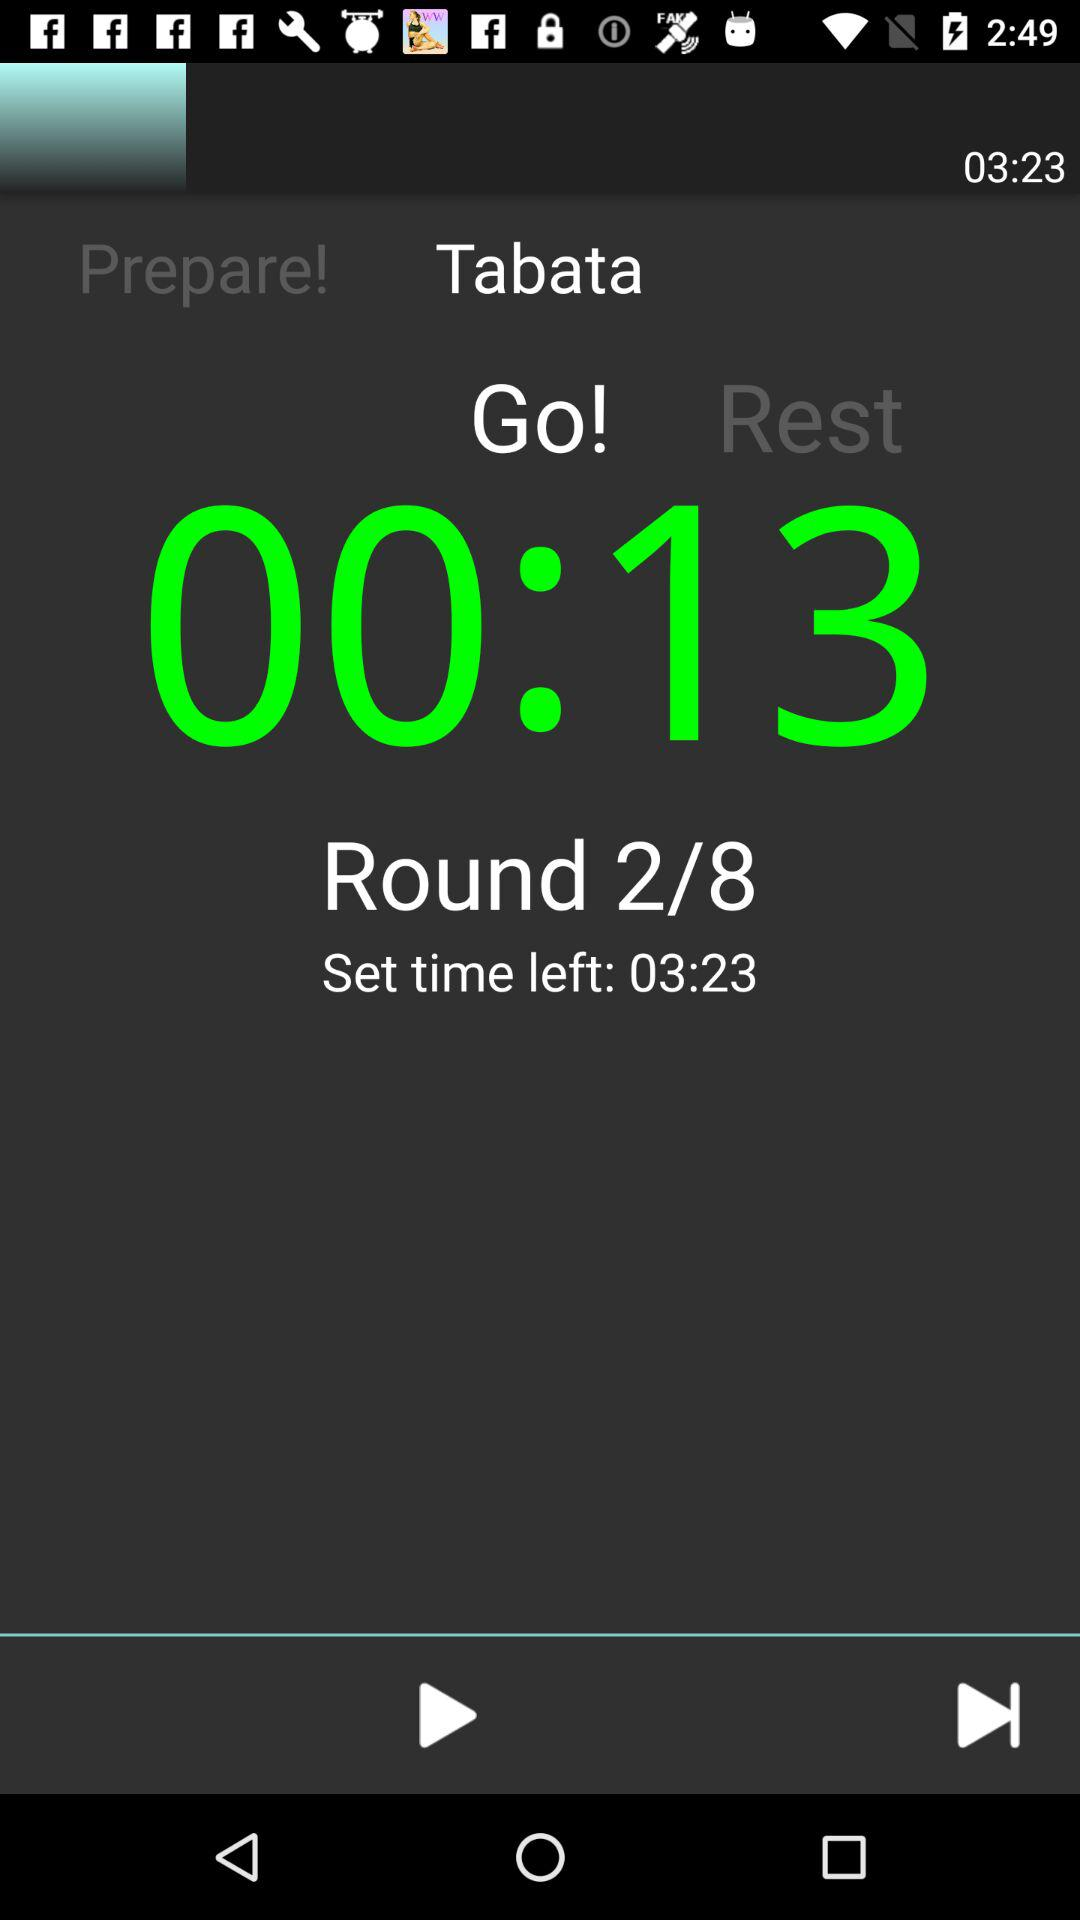What is the current time duration shown on the timer? The current time duration shown on the timer is 13 seconds. 